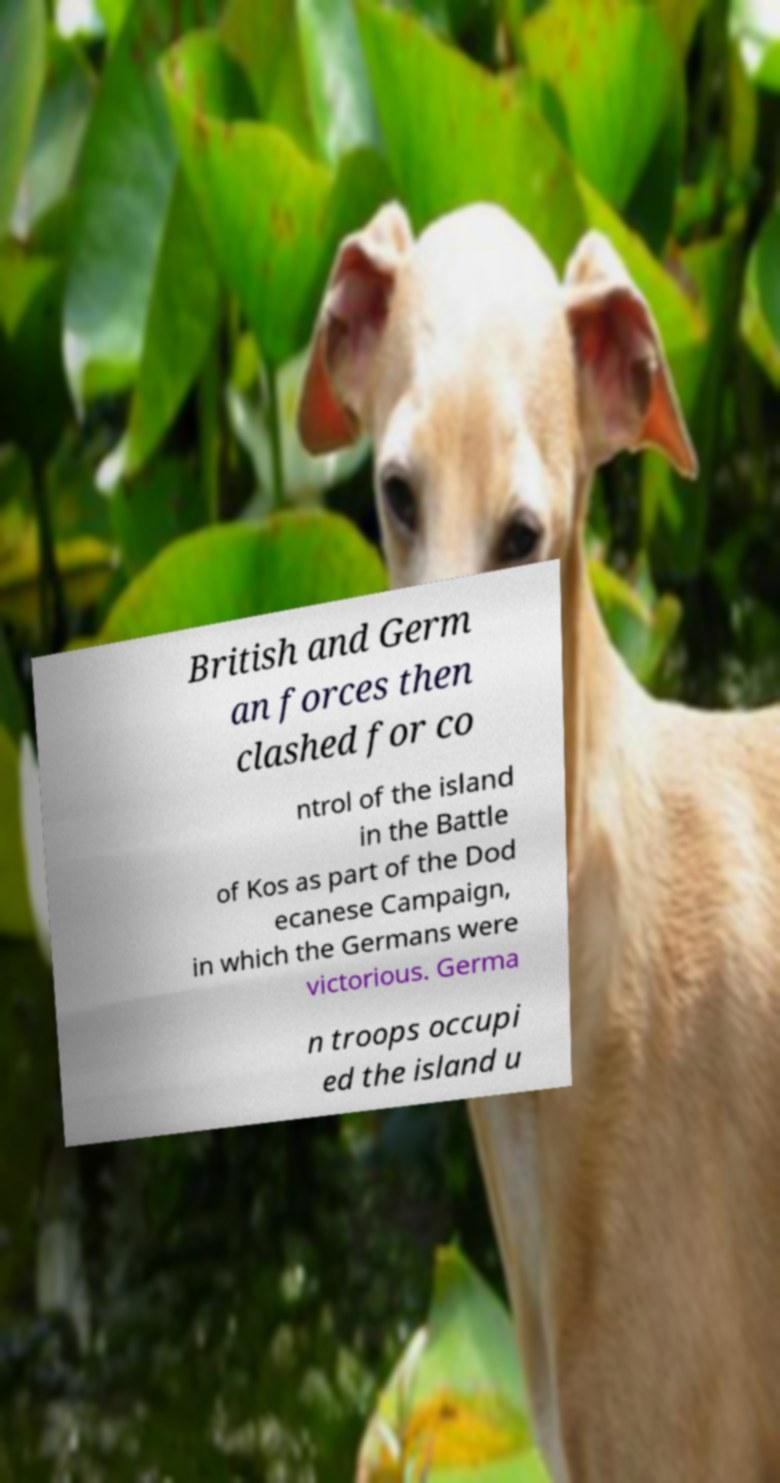I need the written content from this picture converted into text. Can you do that? British and Germ an forces then clashed for co ntrol of the island in the Battle of Kos as part of the Dod ecanese Campaign, in which the Germans were victorious. Germa n troops occupi ed the island u 